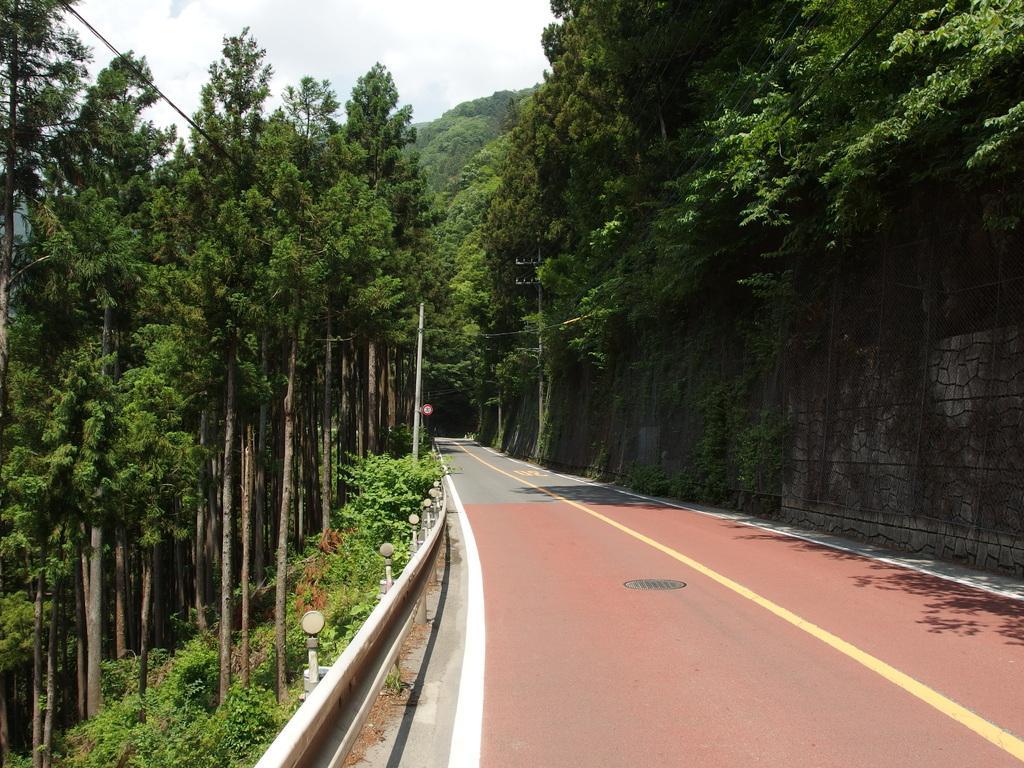In one or two sentences, can you explain what this image depicts? In this image in the middle there are trees, poles, sign boards, road, hills, sky and clouds. 